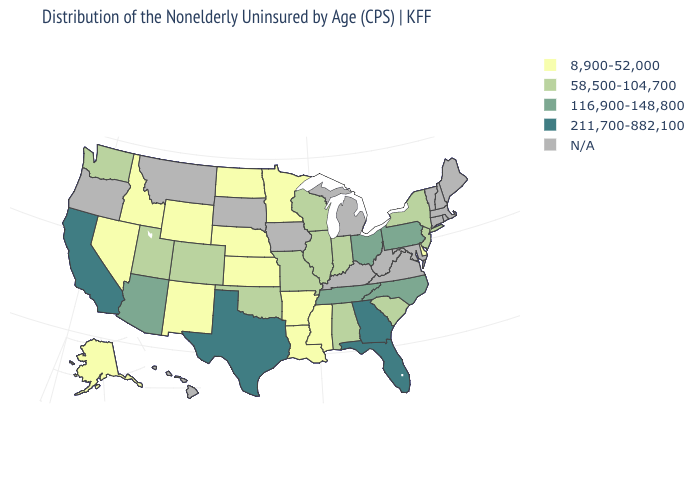What is the value of South Carolina?
Answer briefly. 58,500-104,700. Does the first symbol in the legend represent the smallest category?
Concise answer only. Yes. What is the value of Wyoming?
Be succinct. 8,900-52,000. How many symbols are there in the legend?
Write a very short answer. 5. Name the states that have a value in the range N/A?
Quick response, please. Connecticut, Hawaii, Iowa, Kentucky, Maine, Maryland, Massachusetts, Michigan, Montana, New Hampshire, Oregon, Rhode Island, South Dakota, Vermont, Virginia, West Virginia. What is the lowest value in the West?
Be succinct. 8,900-52,000. What is the lowest value in the South?
Answer briefly. 8,900-52,000. Does Alabama have the lowest value in the USA?
Write a very short answer. No. What is the value of Montana?
Short answer required. N/A. Does the first symbol in the legend represent the smallest category?
Concise answer only. Yes. What is the value of Kansas?
Be succinct. 8,900-52,000. Which states hav the highest value in the South?
Quick response, please. Florida, Georgia, Texas. Which states have the lowest value in the South?
Write a very short answer. Arkansas, Delaware, Louisiana, Mississippi. Name the states that have a value in the range N/A?
Quick response, please. Connecticut, Hawaii, Iowa, Kentucky, Maine, Maryland, Massachusetts, Michigan, Montana, New Hampshire, Oregon, Rhode Island, South Dakota, Vermont, Virginia, West Virginia. 